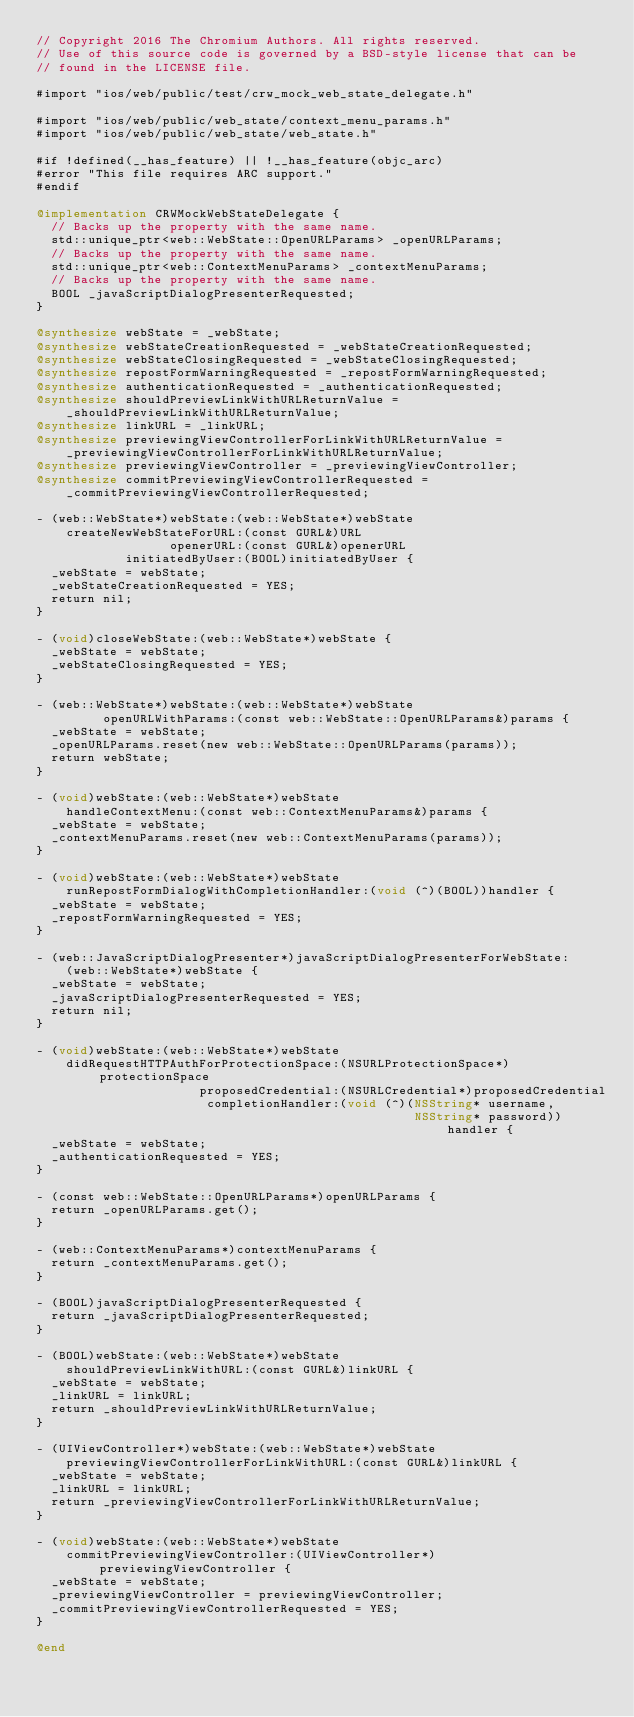<code> <loc_0><loc_0><loc_500><loc_500><_ObjectiveC_>// Copyright 2016 The Chromium Authors. All rights reserved.
// Use of this source code is governed by a BSD-style license that can be
// found in the LICENSE file.

#import "ios/web/public/test/crw_mock_web_state_delegate.h"

#import "ios/web/public/web_state/context_menu_params.h"
#import "ios/web/public/web_state/web_state.h"

#if !defined(__has_feature) || !__has_feature(objc_arc)
#error "This file requires ARC support."
#endif

@implementation CRWMockWebStateDelegate {
  // Backs up the property with the same name.
  std::unique_ptr<web::WebState::OpenURLParams> _openURLParams;
  // Backs up the property with the same name.
  std::unique_ptr<web::ContextMenuParams> _contextMenuParams;
  // Backs up the property with the same name.
  BOOL _javaScriptDialogPresenterRequested;
}

@synthesize webState = _webState;
@synthesize webStateCreationRequested = _webStateCreationRequested;
@synthesize webStateClosingRequested = _webStateClosingRequested;
@synthesize repostFormWarningRequested = _repostFormWarningRequested;
@synthesize authenticationRequested = _authenticationRequested;
@synthesize shouldPreviewLinkWithURLReturnValue =
    _shouldPreviewLinkWithURLReturnValue;
@synthesize linkURL = _linkURL;
@synthesize previewingViewControllerForLinkWithURLReturnValue =
    _previewingViewControllerForLinkWithURLReturnValue;
@synthesize previewingViewController = _previewingViewController;
@synthesize commitPreviewingViewControllerRequested =
    _commitPreviewingViewControllerRequested;

- (web::WebState*)webState:(web::WebState*)webState
    createNewWebStateForURL:(const GURL&)URL
                  openerURL:(const GURL&)openerURL
            initiatedByUser:(BOOL)initiatedByUser {
  _webState = webState;
  _webStateCreationRequested = YES;
  return nil;
}

- (void)closeWebState:(web::WebState*)webState {
  _webState = webState;
  _webStateClosingRequested = YES;
}

- (web::WebState*)webState:(web::WebState*)webState
         openURLWithParams:(const web::WebState::OpenURLParams&)params {
  _webState = webState;
  _openURLParams.reset(new web::WebState::OpenURLParams(params));
  return webState;
}

- (void)webState:(web::WebState*)webState
    handleContextMenu:(const web::ContextMenuParams&)params {
  _webState = webState;
  _contextMenuParams.reset(new web::ContextMenuParams(params));
}

- (void)webState:(web::WebState*)webState
    runRepostFormDialogWithCompletionHandler:(void (^)(BOOL))handler {
  _webState = webState;
  _repostFormWarningRequested = YES;
}

- (web::JavaScriptDialogPresenter*)javaScriptDialogPresenterForWebState:
    (web::WebState*)webState {
  _webState = webState;
  _javaScriptDialogPresenterRequested = YES;
  return nil;
}

- (void)webState:(web::WebState*)webState
    didRequestHTTPAuthForProtectionSpace:(NSURLProtectionSpace*)protectionSpace
                      proposedCredential:(NSURLCredential*)proposedCredential
                       completionHandler:(void (^)(NSString* username,
                                                   NSString* password))handler {
  _webState = webState;
  _authenticationRequested = YES;
}

- (const web::WebState::OpenURLParams*)openURLParams {
  return _openURLParams.get();
}

- (web::ContextMenuParams*)contextMenuParams {
  return _contextMenuParams.get();
}

- (BOOL)javaScriptDialogPresenterRequested {
  return _javaScriptDialogPresenterRequested;
}

- (BOOL)webState:(web::WebState*)webState
    shouldPreviewLinkWithURL:(const GURL&)linkURL {
  _webState = webState;
  _linkURL = linkURL;
  return _shouldPreviewLinkWithURLReturnValue;
}

- (UIViewController*)webState:(web::WebState*)webState
    previewingViewControllerForLinkWithURL:(const GURL&)linkURL {
  _webState = webState;
  _linkURL = linkURL;
  return _previewingViewControllerForLinkWithURLReturnValue;
}

- (void)webState:(web::WebState*)webState
    commitPreviewingViewController:(UIViewController*)previewingViewController {
  _webState = webState;
  _previewingViewController = previewingViewController;
  _commitPreviewingViewControllerRequested = YES;
}

@end
</code> 